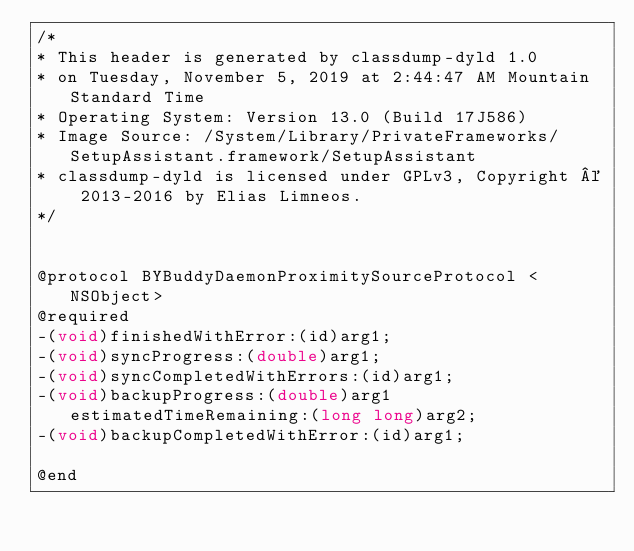<code> <loc_0><loc_0><loc_500><loc_500><_C_>/*
* This header is generated by classdump-dyld 1.0
* on Tuesday, November 5, 2019 at 2:44:47 AM Mountain Standard Time
* Operating System: Version 13.0 (Build 17J586)
* Image Source: /System/Library/PrivateFrameworks/SetupAssistant.framework/SetupAssistant
* classdump-dyld is licensed under GPLv3, Copyright © 2013-2016 by Elias Limneos.
*/


@protocol BYBuddyDaemonProximitySourceProtocol <NSObject>
@required
-(void)finishedWithError:(id)arg1;
-(void)syncProgress:(double)arg1;
-(void)syncCompletedWithErrors:(id)arg1;
-(void)backupProgress:(double)arg1 estimatedTimeRemaining:(long long)arg2;
-(void)backupCompletedWithError:(id)arg1;

@end

</code> 